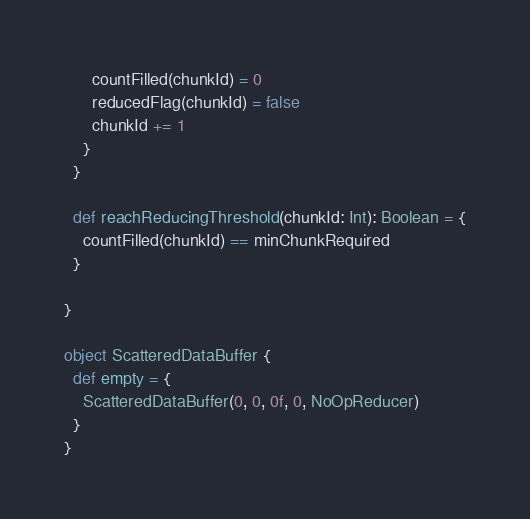<code> <loc_0><loc_0><loc_500><loc_500><_Scala_>      countFilled(chunkId) = 0
      reducedFlag(chunkId) = false
      chunkId += 1
    }
  }

  def reachReducingThreshold(chunkId: Int): Boolean = {
    countFilled(chunkId) == minChunkRequired
  }

}

object ScatteredDataBuffer {
  def empty = {
    ScatteredDataBuffer(0, 0, 0f, 0, NoOpReducer)
  }
}
</code> 